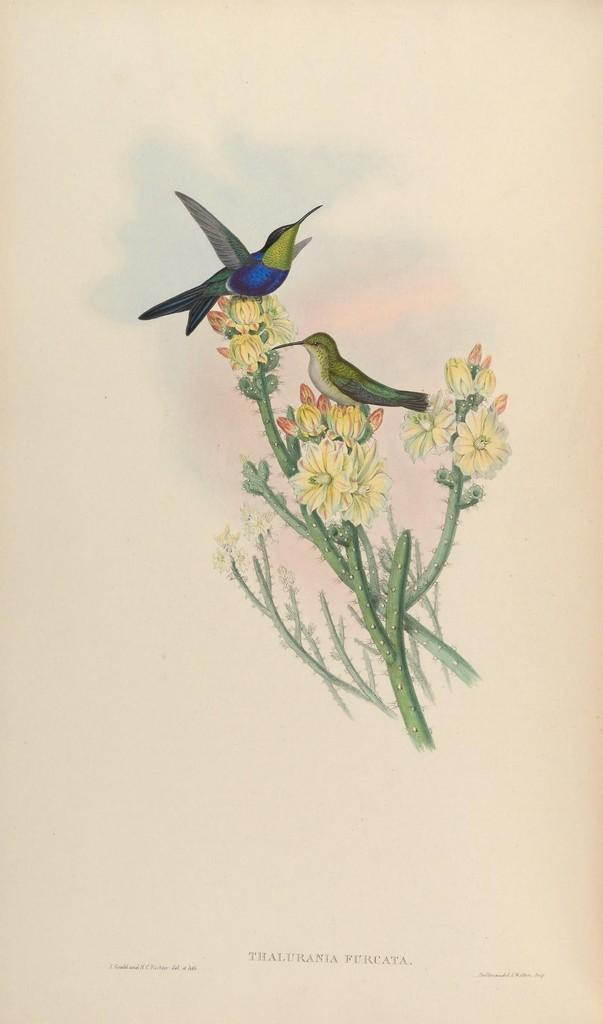What is the main subject of the painting in the image? The painting depicts flower plants. Are there any other elements present in the painting besides the flower plants? Yes, the painting also includes birds. Can you see any guns in the painting? No, there are no guns present in the painting; it features flower plants and birds. What type of ray is visible in the painting? There is no ray visible in the painting; it only includes flower plants and birds. 